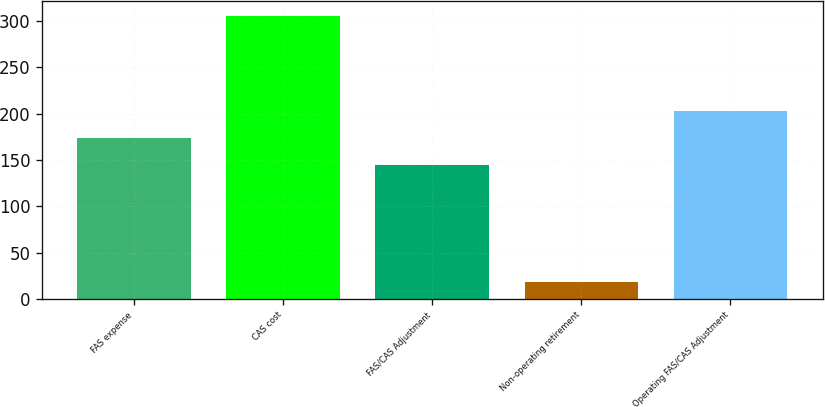Convert chart to OTSL. <chart><loc_0><loc_0><loc_500><loc_500><bar_chart><fcel>FAS expense<fcel>CAS cost<fcel>FAS/CAS Adjustment<fcel>Non-operating retirement<fcel>Operating FAS/CAS Adjustment<nl><fcel>173.8<fcel>306<fcel>145<fcel>18<fcel>202.6<nl></chart> 